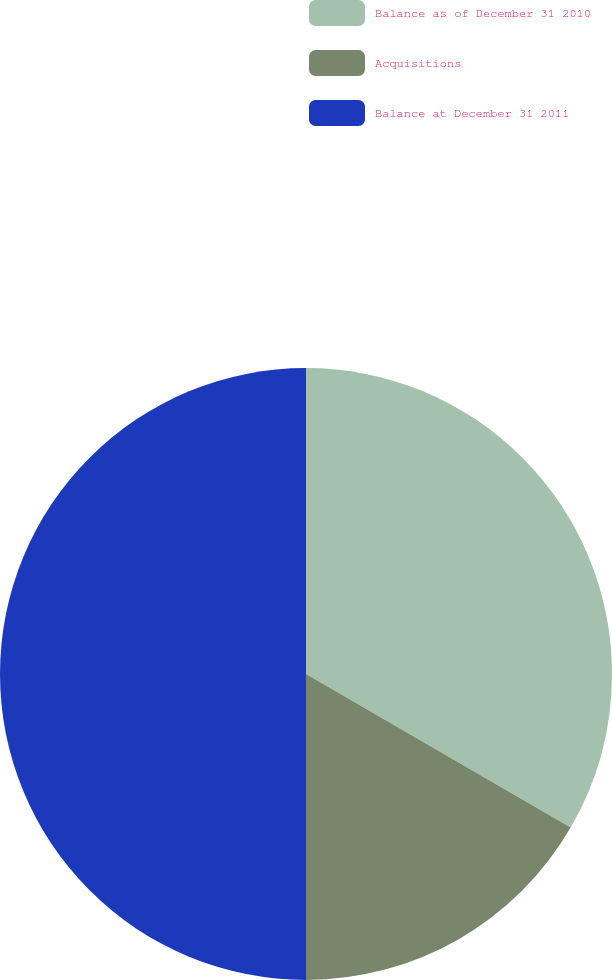Convert chart. <chart><loc_0><loc_0><loc_500><loc_500><pie_chart><fcel>Balance as of December 31 2010<fcel>Acquisitions<fcel>Balance at December 31 2011<nl><fcel>33.37%<fcel>16.63%<fcel>50.0%<nl></chart> 